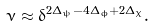<formula> <loc_0><loc_0><loc_500><loc_500>\nu \approx \delta ^ { 2 \Delta _ { \psi } - 4 \Delta _ { \phi } + 2 \Delta _ { \chi } } .</formula> 